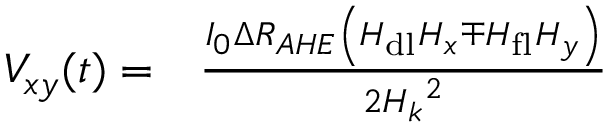Convert formula to latex. <formula><loc_0><loc_0><loc_500><loc_500>\begin{array} { r l } { V _ { x y } ( t ) = } & \frac { I _ { 0 } \Delta R _ { A H E } \left ( H _ { d l } H _ { x } \mp H _ { f l } H _ { y } \right ) } { 2 { H _ { k } } ^ { 2 } } } \end{array}</formula> 